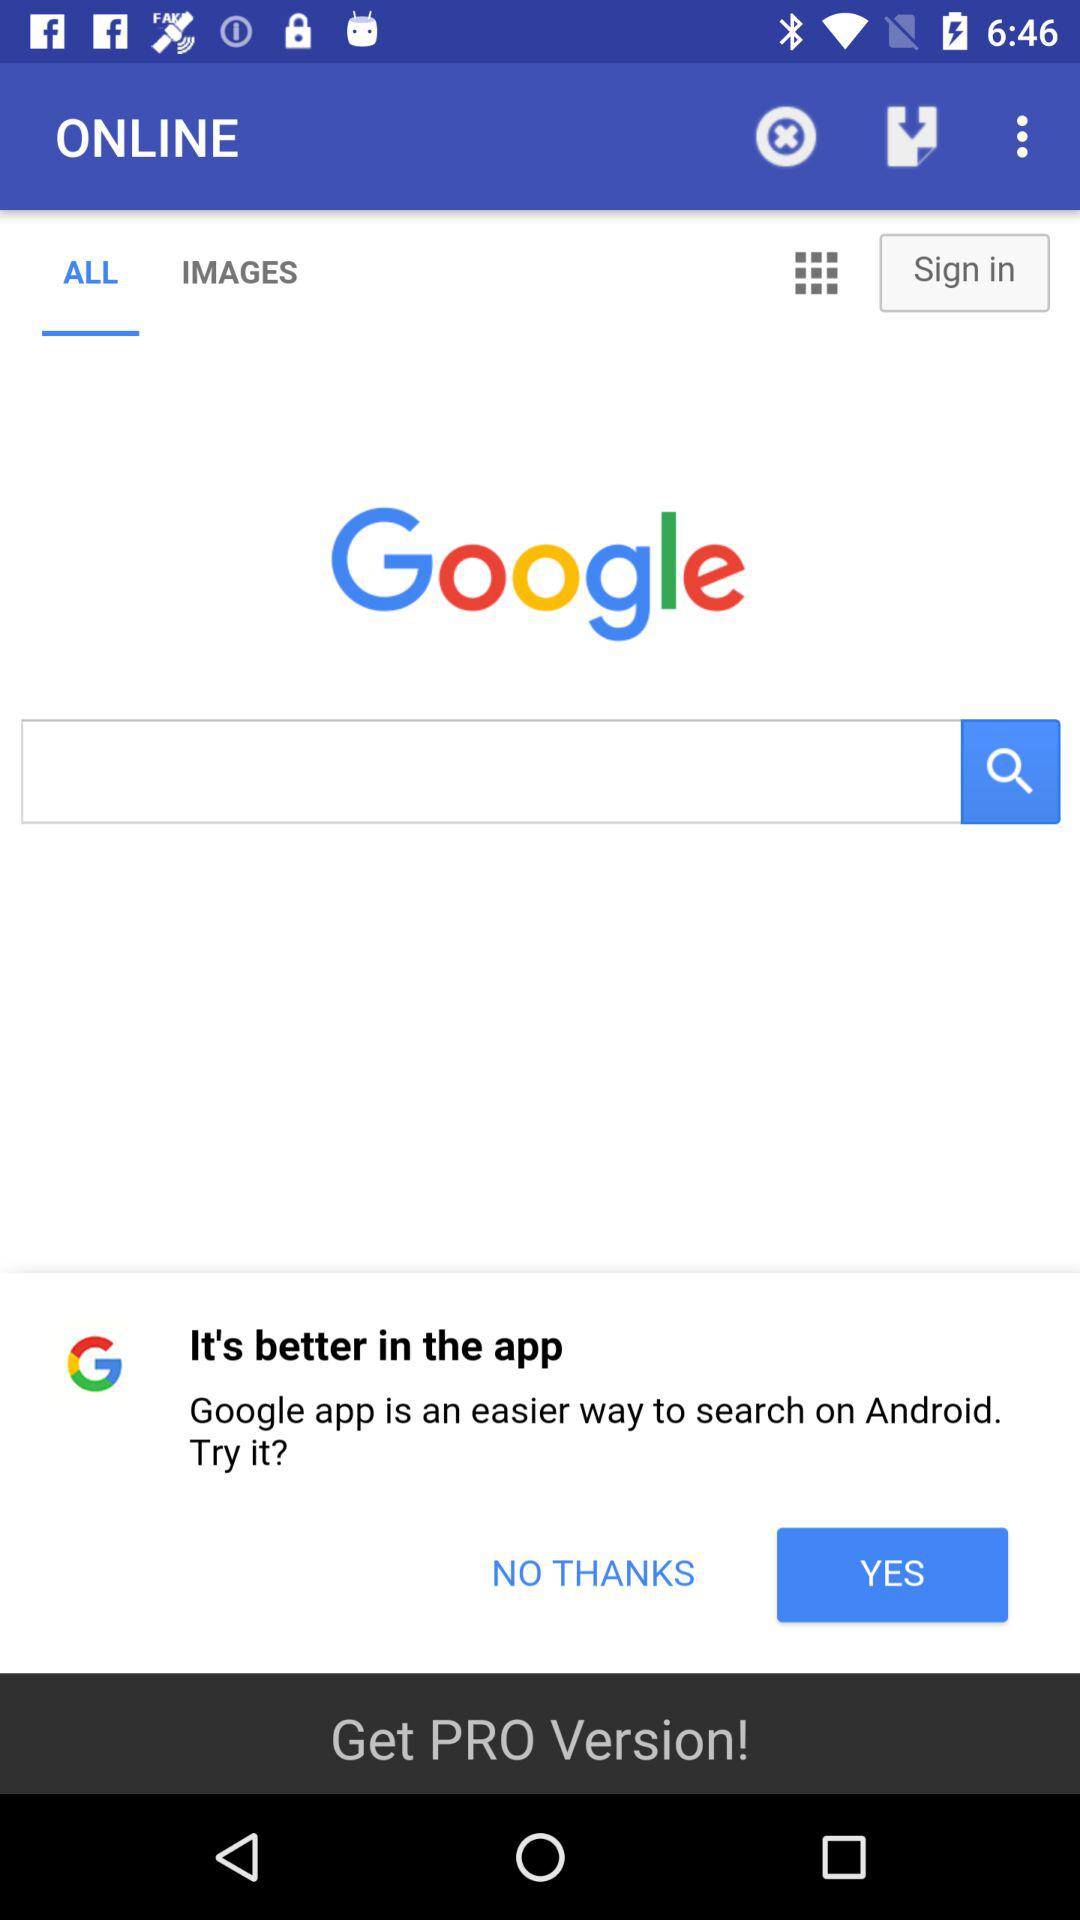What is the search engine? The search engine is "Google". 